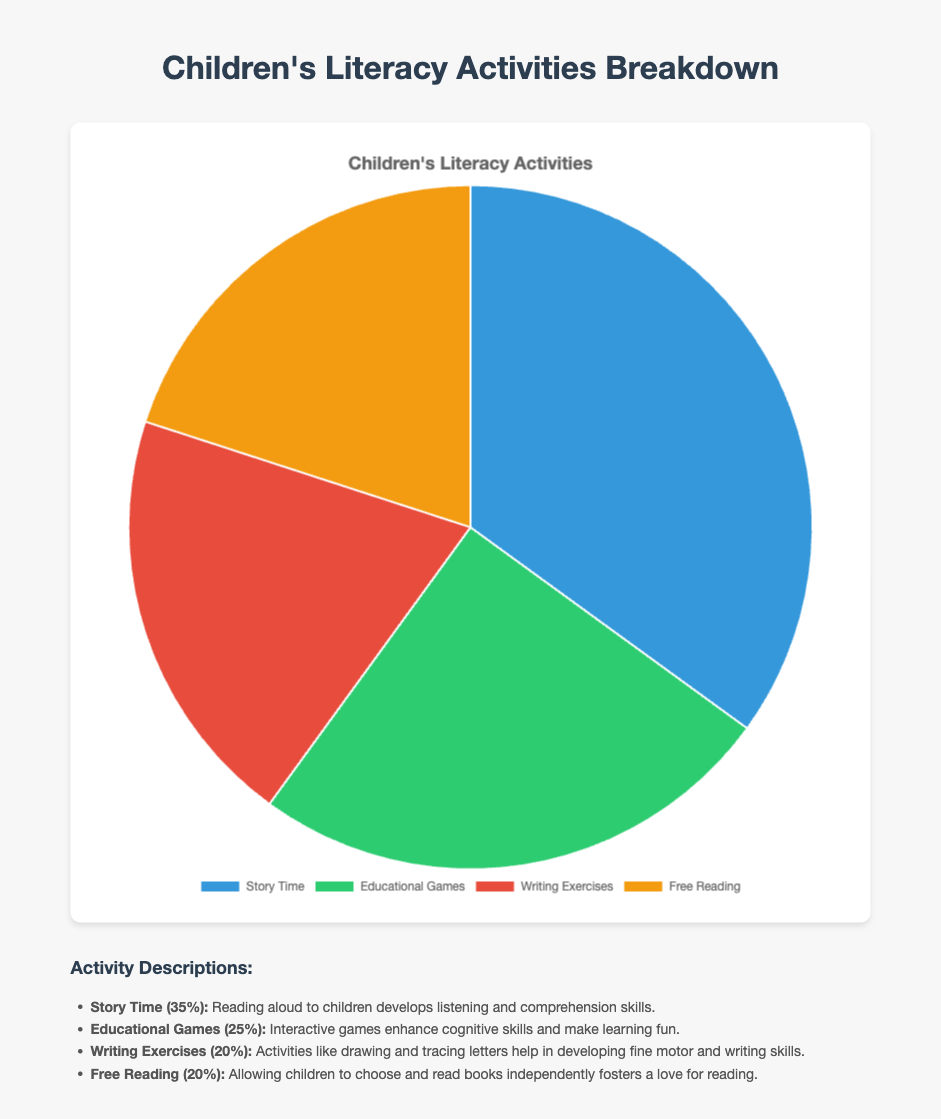Which activity makes up the largest percentage of Children's Literacy Activities? The activity with the largest percentage is the one with the highest numeric value in the chart. In this figure, Story Time has the highest percentage of 35%.
Answer: Story Time How do the percentages of Writing Exercises and Free Reading compare? Both Writing Exercises and Free Reading have the same percentage value in the pie chart, which is 20%.
Answer: They are equal What is the combined percentage of Story Time and Educational Games? Add the percentages of Story Time (35%) and Educational Games (25%) to find the combined percentage. 35% + 25% = 60%
Answer: 60% What is the difference between the percentages of Educational Games and Writing Exercises? Subtract the percentage of Writing Exercises (20%) from the percentage of Educational Games (25%). 25% - 20% = 5%
Answer: 5% Which segment is represented by the color blue in the pie chart? By referring to the color legend, Story Time is represented by the color blue in the chart.
Answer: Story Time What proportion of the activities are devoted to reading (either Story Time or Free Reading)? Add the percentages of Story Time (35%) and Free Reading (20%). 35% + 20% = 55%
Answer: 55% If you were to compare the visual sizes of the segments corresponding to Writing Exercises and Free Reading, what would you observe? Since Writing Exercises and Free Reading both have the same percentage (20%), their segments in the pie chart will be visually identical in size.
Answer: Identical in size What percentage of the activities fall under non-reading-related activities (Educational Games and Writing Exercises)? Add the percentages of Educational Games (25%) and Writing Exercises (20%). 25% + 20% = 45%
Answer: 45% If each activity represents a group of children, and there are 100 children in total, how many children participate in Story Time? Calculate the number of children based on the percentage for Story Time. 35% of 100 children is 35 children. 0.35 * 100 = 35
Answer: 35 